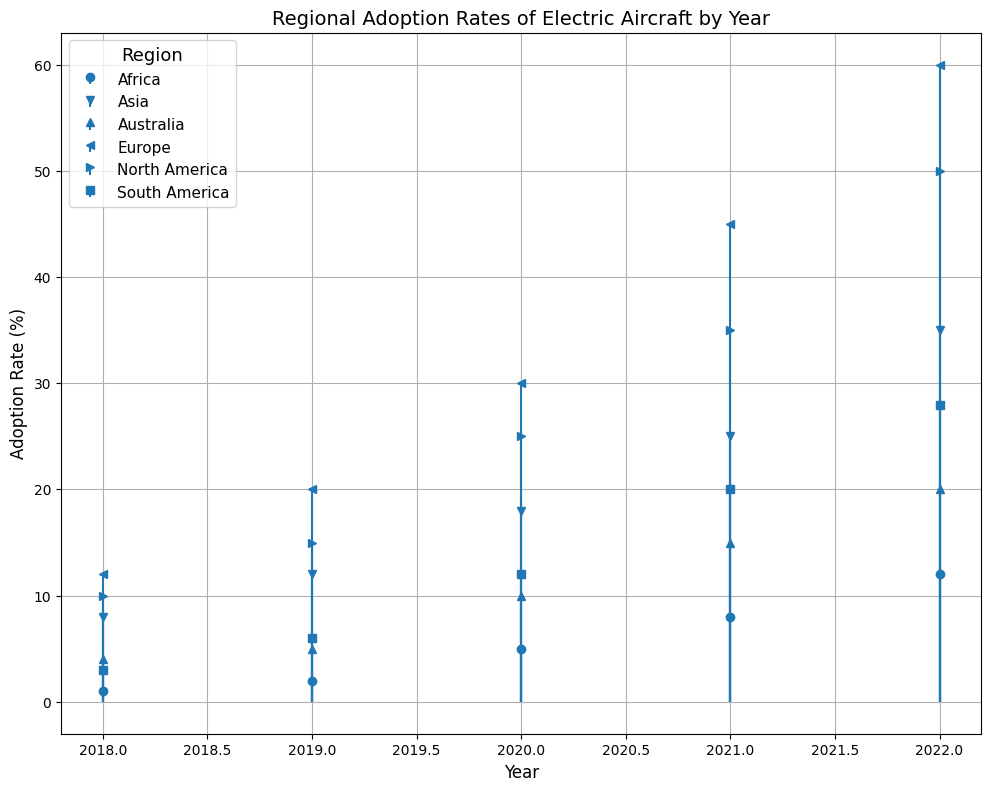What was the adoption rate of electric aircraft in Europe in 2018? Look at the stem plot for the marker representing Europe in the year 2018. The plotted point shows an adoption rate.
Answer: 12 Which region had the highest adoption rate in 2022? Locate the highest point on the stem plot for the year 2022. The region with the marker at the highest position is Europe.
Answer: Europe How did the adoption rate change in North America from 2020 to 2021? Compare the markers for North America in the years 2020 and 2021. The marker moves from 25% in 2020 to 35% in 2021, indicating an increase of 10%.
Answer: Increased by 10% Which year saw the greatest increase in adoption rate for Asia? Compare the differences in adoption rates for Asia between consecutive years. The difference between 2021 and 2022 (10%) is the highest.
Answer: 2021 to 2022 Calculate the average adoption rate in Africa over the five-year period from 2018 to 2022. Add up the adoption rates for Africa from each year and divide by the number of years: (1+2+5+8+12)/5 = 28/5 = 5.6%.
Answer: 5.6% Was the adoption rate in South America in 2019 higher or lower than in Australia in the same year? Compare the markers for South America and Australia in the year 2019. The rate for South America (6%) is higher than Australia (5%).
Answer: Higher What is the difference in adoption rates between Europe and Asia in 2020? Subtract the adoption rate of Asia from Europe for the year 2020: 30 - 18 = 12%.
Answer: 12% Did all regions show a continuous increase in adoption rates every year? Observe the trend lines for each region across the years. Each region shows a continuous upward trend without any declines.
Answer: Yes 